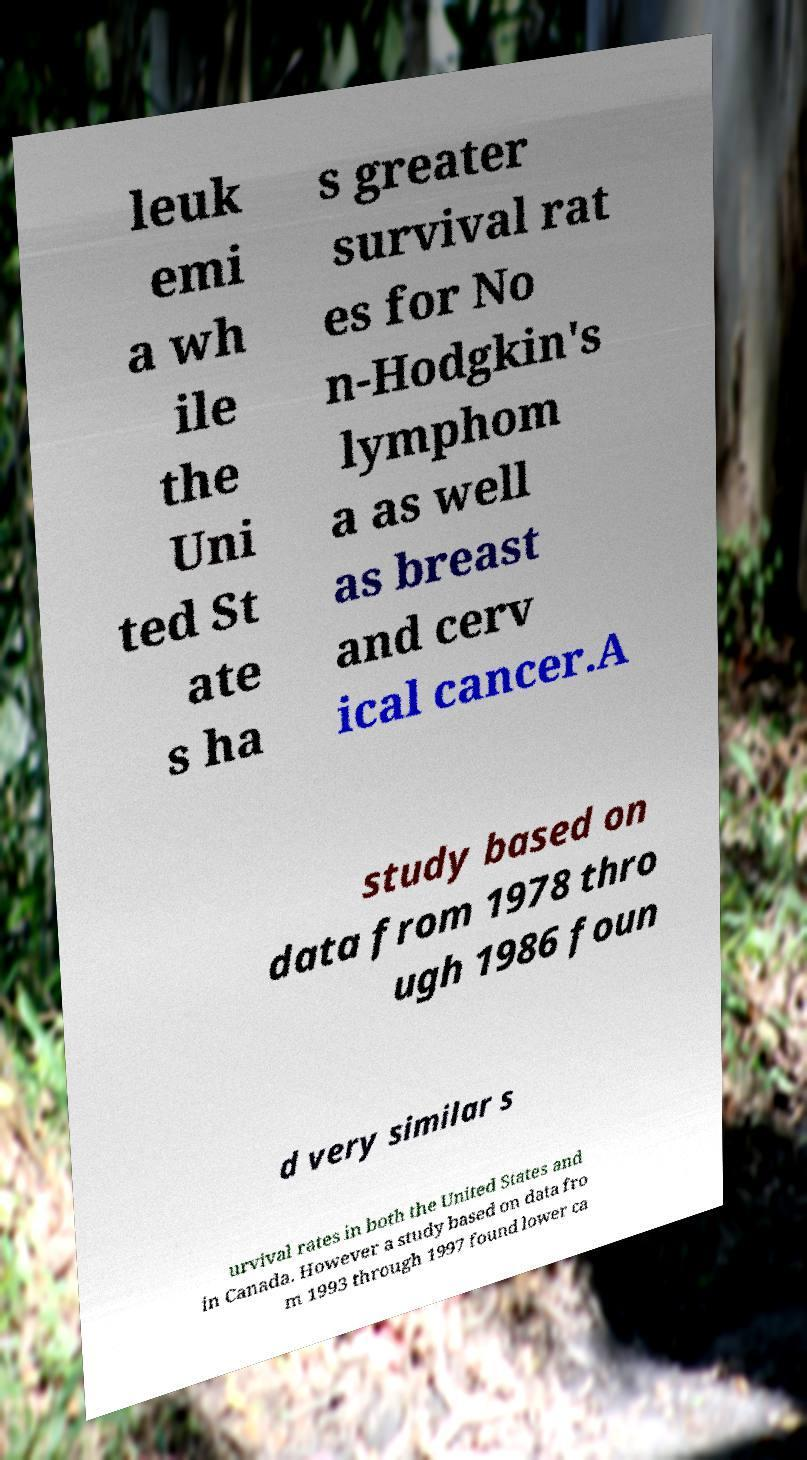Please identify and transcribe the text found in this image. leuk emi a wh ile the Uni ted St ate s ha s greater survival rat es for No n-Hodgkin's lymphom a as well as breast and cerv ical cancer.A study based on data from 1978 thro ugh 1986 foun d very similar s urvival rates in both the United States and in Canada. However a study based on data fro m 1993 through 1997 found lower ca 